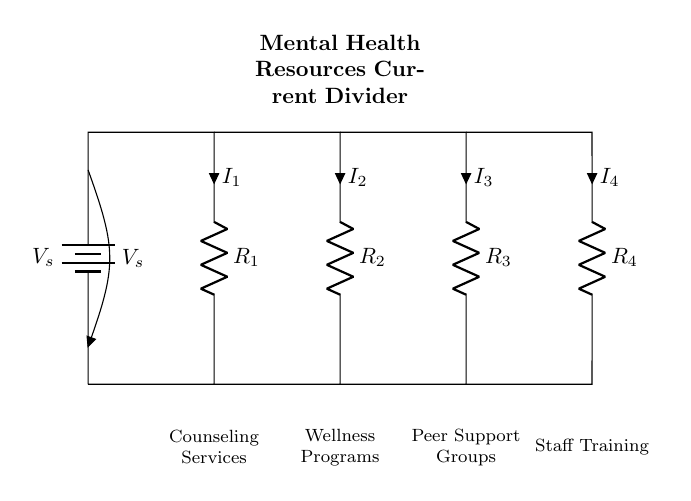What is the total number of resistors in this circuit? There are four resistors shown in the circuit diagram, labeled as R1, R2, R3, and R4.
Answer: 4 What is the common voltage supplied to the circuit? The circuit is supplied by a voltage source labeled as V_s, which represents the total voltage provided to the entire circuit.
Answer: V_s What is the role of the current divider in this circuit? The current divider distributes the total current from the voltage source among the different branches (resistors) based on their resistance values, allowing for efficient power distribution to mental health resources.
Answer: Distributing current What is the sum of the currents through all resistors? In a current divider, the total current (It) entering the circuit is equal to the sum of the currents going through each resistor, hence I1 + I2 + I3 + I4 equals It.
Answer: It = I1 + I2 + I3 + I4 What type of circuit is represented here? This is specifically a current divider circuit because it consists of multiple resistors connected in parallel, which divides the input current among them.
Answer: Current divider Which resource is connected to the resistor R3? The resource connected to the resistor R3 is labeled as "Peer Support Groups" in the diagram, indicating its corresponding function in the current distribution.
Answer: Peer Support Groups If the resistance value of R1 is increased, what happens to I1? If the resistance value of R1 increases, according to the principles of a current divider, the current I1 will decrease as current tends to flow more through branches with lower resistance.
Answer: I1 decreases 